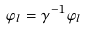<formula> <loc_0><loc_0><loc_500><loc_500>\varphi _ { l } = \gamma ^ { - 1 } \varphi _ { l }</formula> 